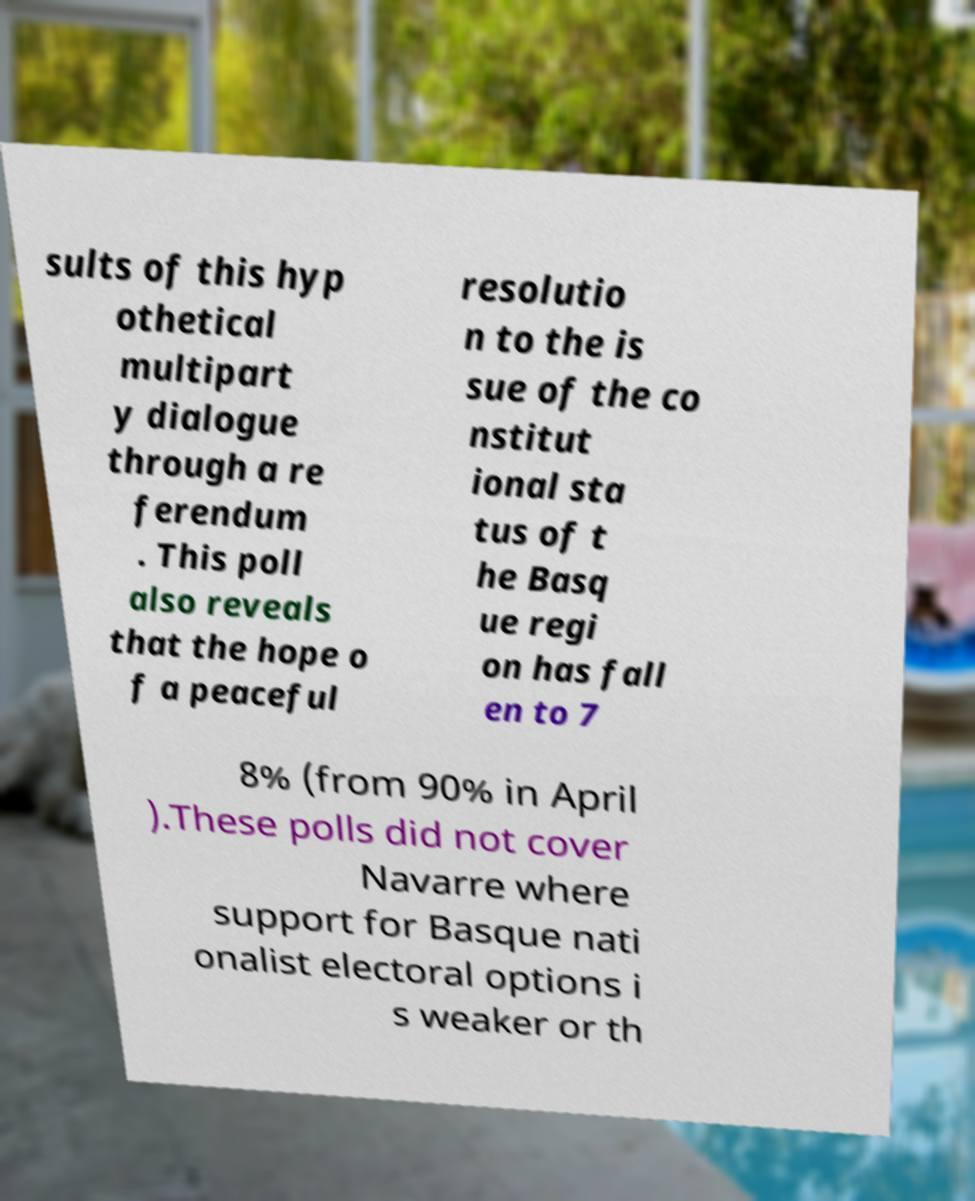Could you assist in decoding the text presented in this image and type it out clearly? sults of this hyp othetical multipart y dialogue through a re ferendum . This poll also reveals that the hope o f a peaceful resolutio n to the is sue of the co nstitut ional sta tus of t he Basq ue regi on has fall en to 7 8% (from 90% in April ).These polls did not cover Navarre where support for Basque nati onalist electoral options i s weaker or th 